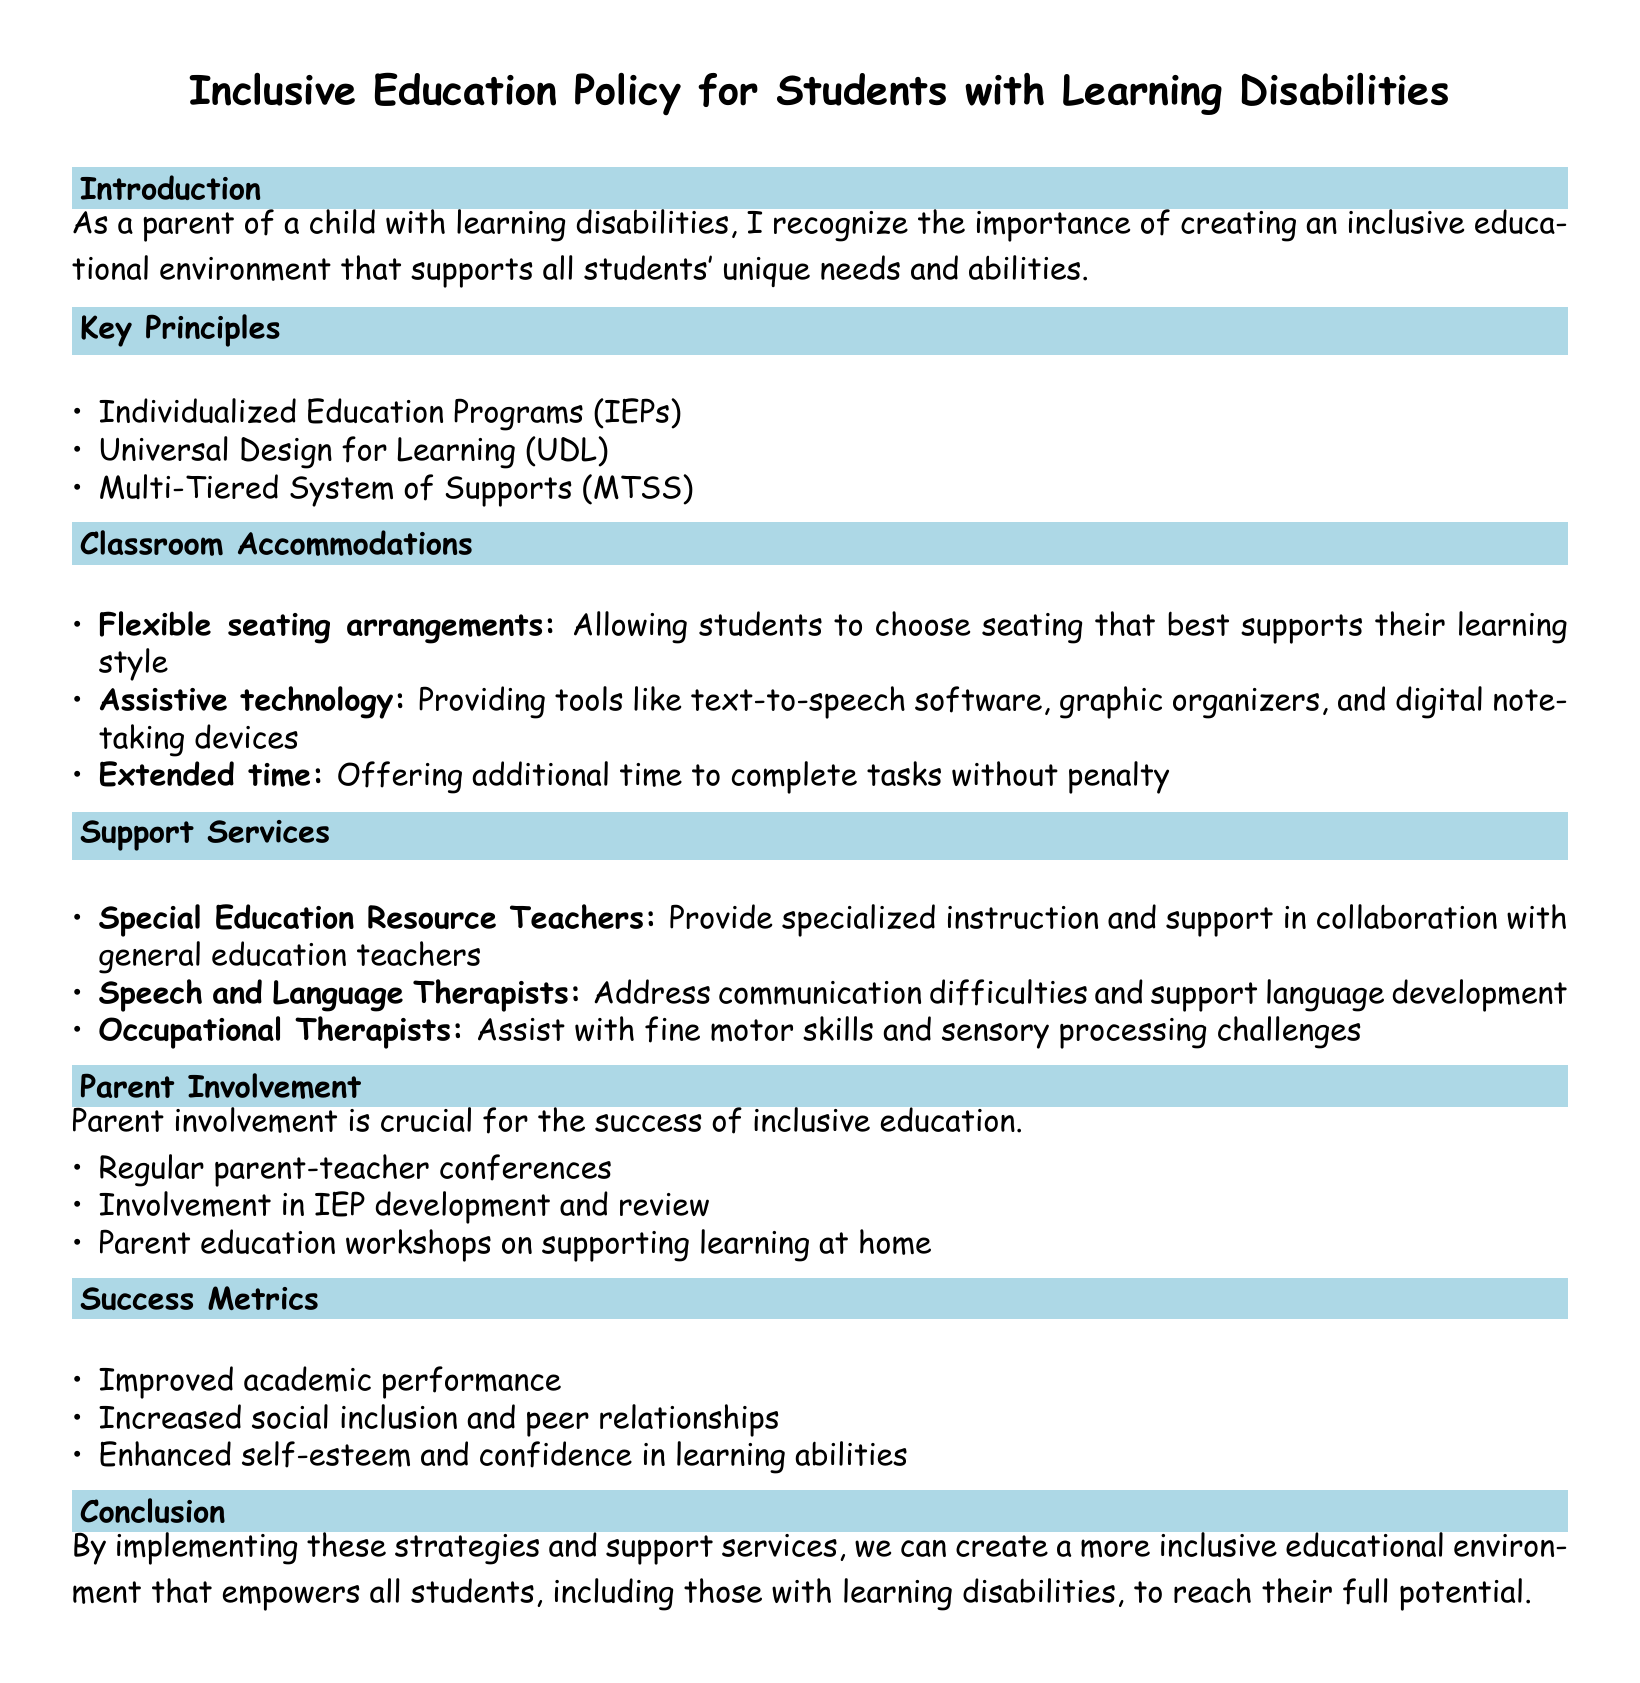What is the first key principle mentioned? The first key principle is listed under the Key Principles section, which is Individualized Education Programs (IEPs).
Answer: Individualized Education Programs (IEPs) What type of seating arrangement is suggested? The suggested seating arrangement is described in the Classroom Accommodations section, specifically to allow students to choose seating that supports their learning style.
Answer: Flexible seating arrangements Who provides specialized instruction in collaboration with general education teachers? This role is specified in the Support Services section as being performed by Special Education Resource Teachers.
Answer: Special Education Resource Teachers What is one way to encourage parent involvement? The document highlights several ways to involve parents, including regular parent-teacher conferences.
Answer: Regular parent-teacher conferences What is one success metric mentioned? One metric for success is provided in the Success Metrics section, focusing on improved academic performance.
Answer: Improved academic performance Which professional assists with fine motor skills? The Support Services section specifies that Occupational Therapists assist with fine motor skills and sensory processing challenges.
Answer: Occupational Therapists How many key principles are listed in the document? The total number of key principles can be counted from the Key Principles section, which lists three items.
Answer: Three What does UDL stand for? UDL is mentioned in the Key Principles and stands for Universal Design for Learning.
Answer: Universal Design for Learning What support is provided to address communication difficulties? The Support Services section mentions that Speech and Language Therapists provide support for communication difficulties.
Answer: Speech and Language Therapists 